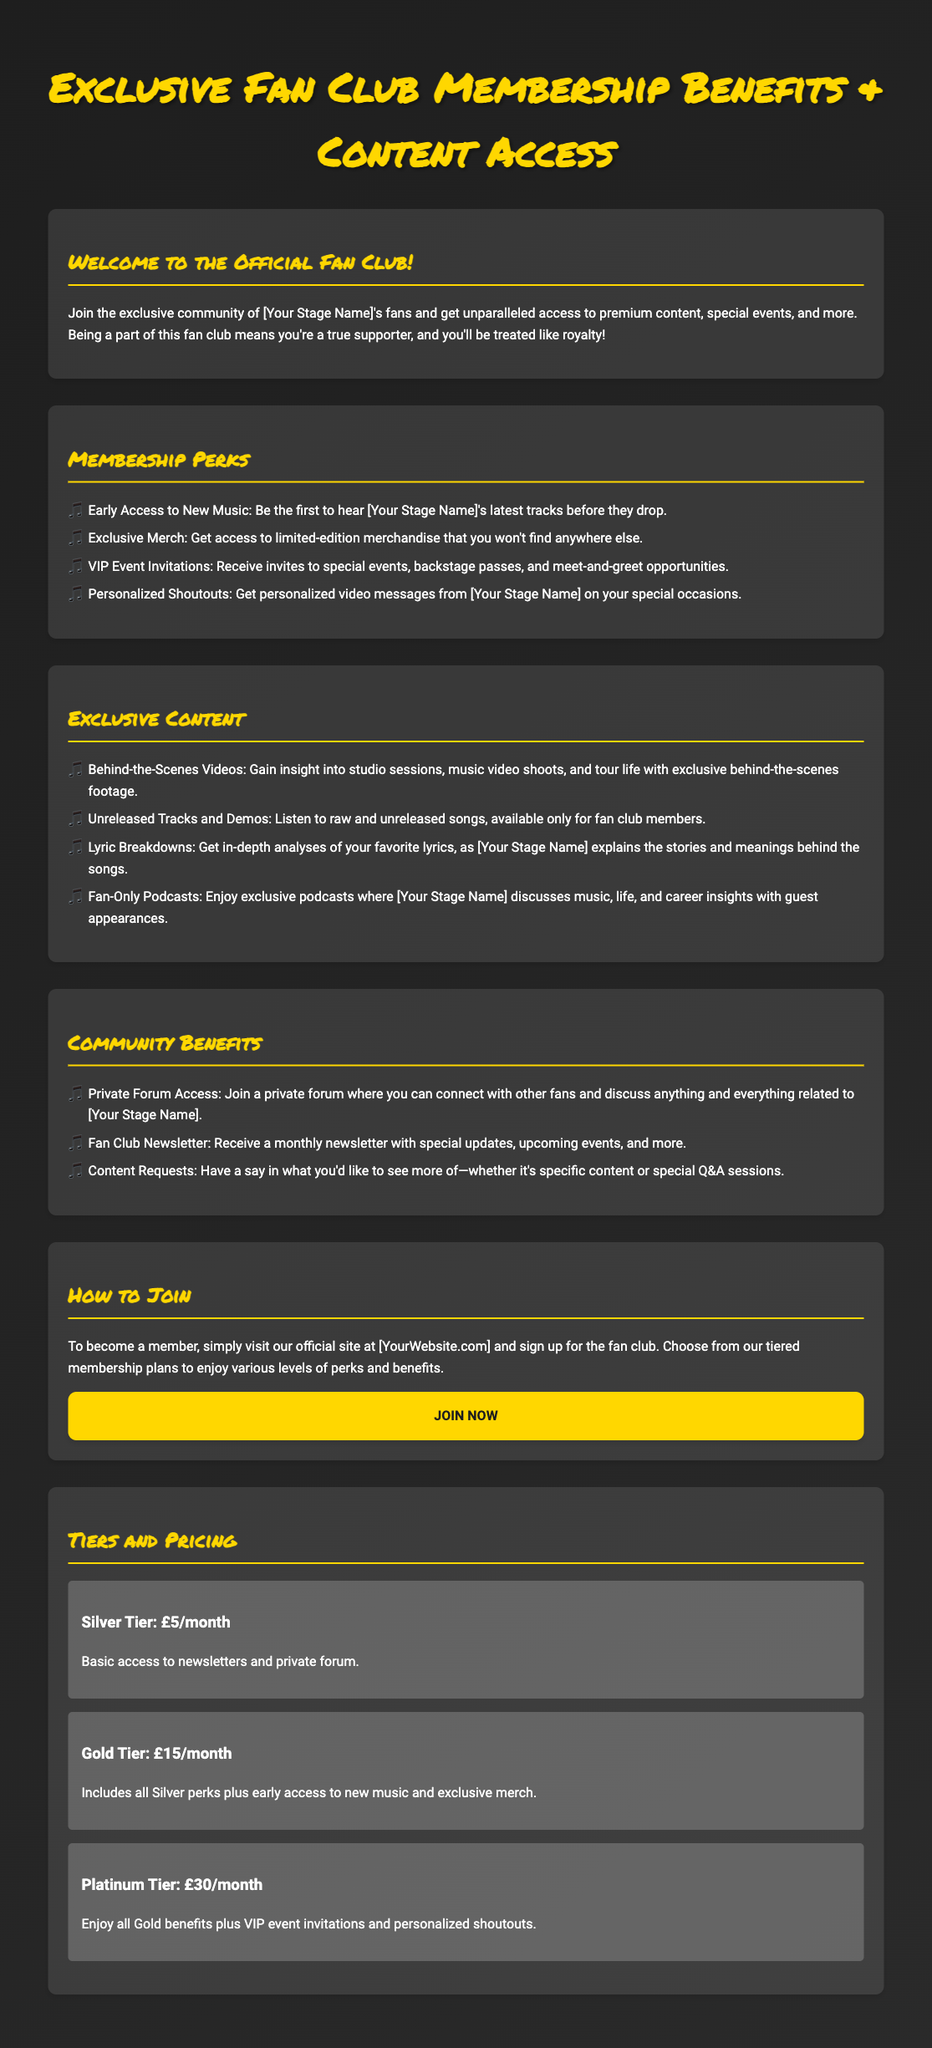What are the tiers available for membership? The document lists three tiers of membership: Silver Tier, Gold Tier, and Platinum Tier.
Answer: Silver, Gold, Platinum What is the price of the Gold Tier? The Gold Tier is priced at £15 per month as stated in the tiers and pricing section.
Answer: £15/month What kind of personalized content can members receive? Members can receive personalized video messages from [Your Stage Name] on their special occasions.
Answer: Personalized video messages What exclusive content is offered to fan club members? Members can access behind-the-scenes videos, unreleased tracks, lyric breakdowns, and fan-only podcasts.
Answer: Behind-the-scenes videos, unreleased tracks, lyric breakdowns, fan-only podcasts How can one join the fan club? To join, individuals should visit the official site at [YourWebsite.com].
Answer: Visit [YourWebsite.com] What is included in the Silver Tier membership? The Silver Tier provides basic access to newsletters and private forum.
Answer: Newsletters and private forum How often do fans receive the newsletter? The newsletter is received monthly according to the community benefits section of the document.
Answer: Monthly What is the benefit of the Platinum Tier? The Platinum Tier includes all Gold benefits plus VIP event invitations and personalized shoutouts.
Answer: VIP event invitations and personalized shoutouts How many membership perks are listed? Four membership perks are listed in the membership perks section.
Answer: Four 